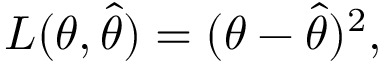Convert formula to latex. <formula><loc_0><loc_0><loc_500><loc_500>L ( \theta , { \hat { \theta } } ) = ( \theta - { \hat { \theta } } ) ^ { 2 } ,</formula> 